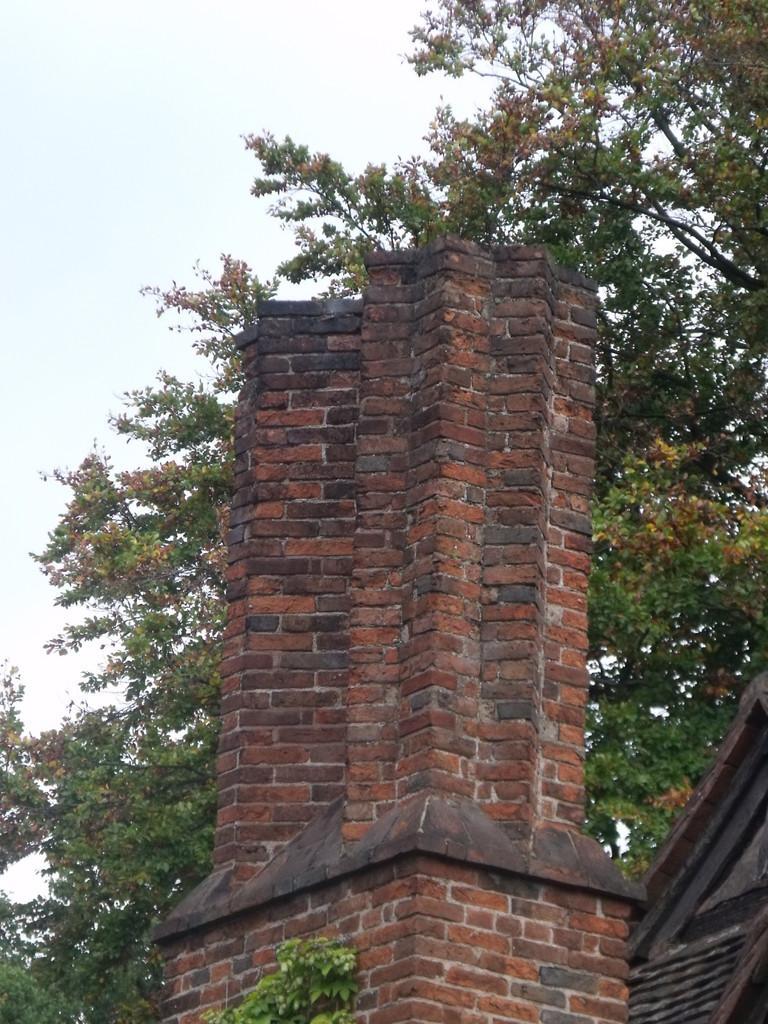Please provide a concise description of this image. In the image in the center, we can see the sky, clouds, trees and building. 